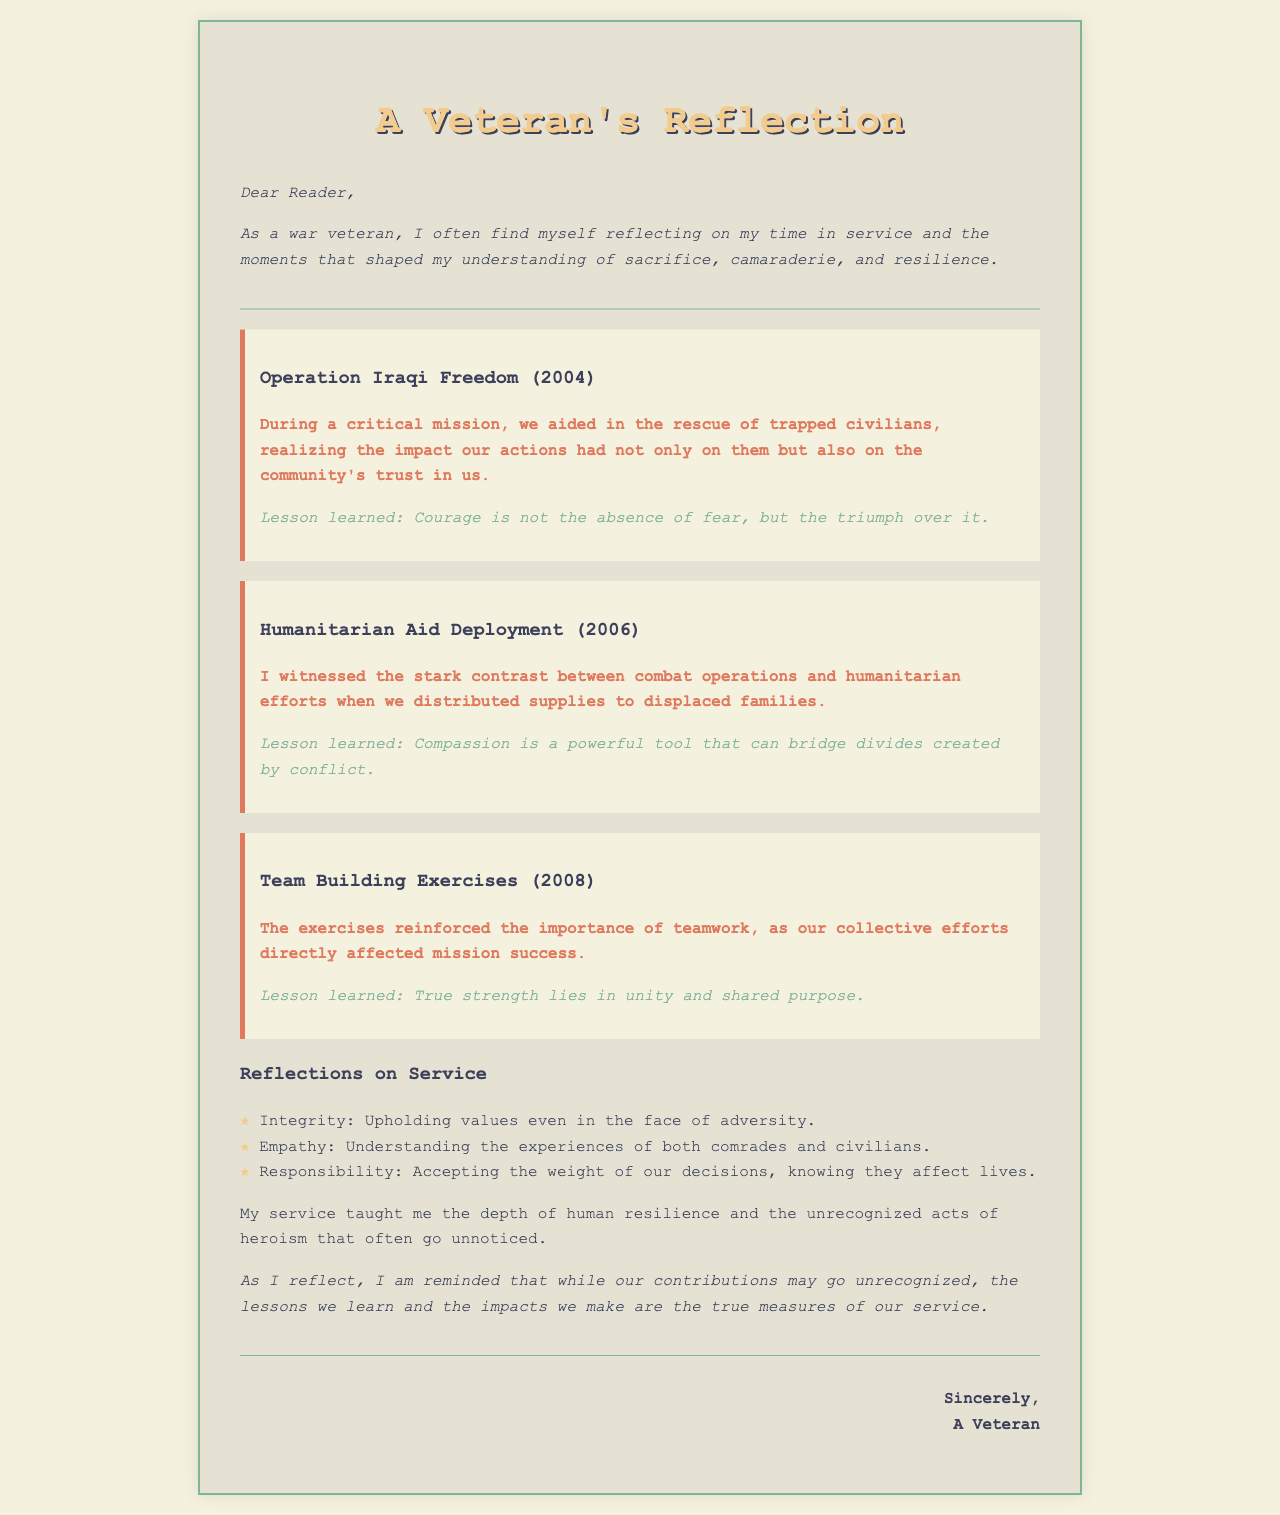what year was Operation Iraqi Freedom? The year mentioned for Operation Iraqi Freedom is 2004.
Answer: 2004 what is a key moment described in 2006? The letter mentions a humanitarian aid deployment as a key moment in 2006.
Answer: Humanitarian Aid Deployment what lesson was learned from rescuing trapped civilians? The lesson learned during the rescue operation is stated as "Courage is not the absence of fear, but the triumph over it."
Answer: Courage is not the absence of fear, but the triumph over it how did team-building exercises impact mission success? The document states that the exercises reinforced the importance of teamwork, affecting mission success positively.
Answer: Importance of teamwork what are two key lessons mentioned in the document? The document highlights "Compassion is a powerful tool that can bridge divides created by conflict" and "True strength lies in unity and shared purpose."
Answer: Compassion and unity what values are listed in the reflections on service? The reflections include integrity, empathy, and responsibility as key values learned during service.
Answer: Integrity, empathy, responsibility who is the letter addressed to? The letter begins with "Dear Reader," indicating it is addressed to the general audience.
Answer: Dear Reader what impact did the distribution of supplies have on the families? The impact noted was the stark contrast between combat and humanitarian efforts when supplies were distributed.
Answer: Stark contrast between combat and humanitarian efforts what color is used for the background of the letter? The background color of the letter is described as #f4f1de in the styling.
Answer: #f4f1de 